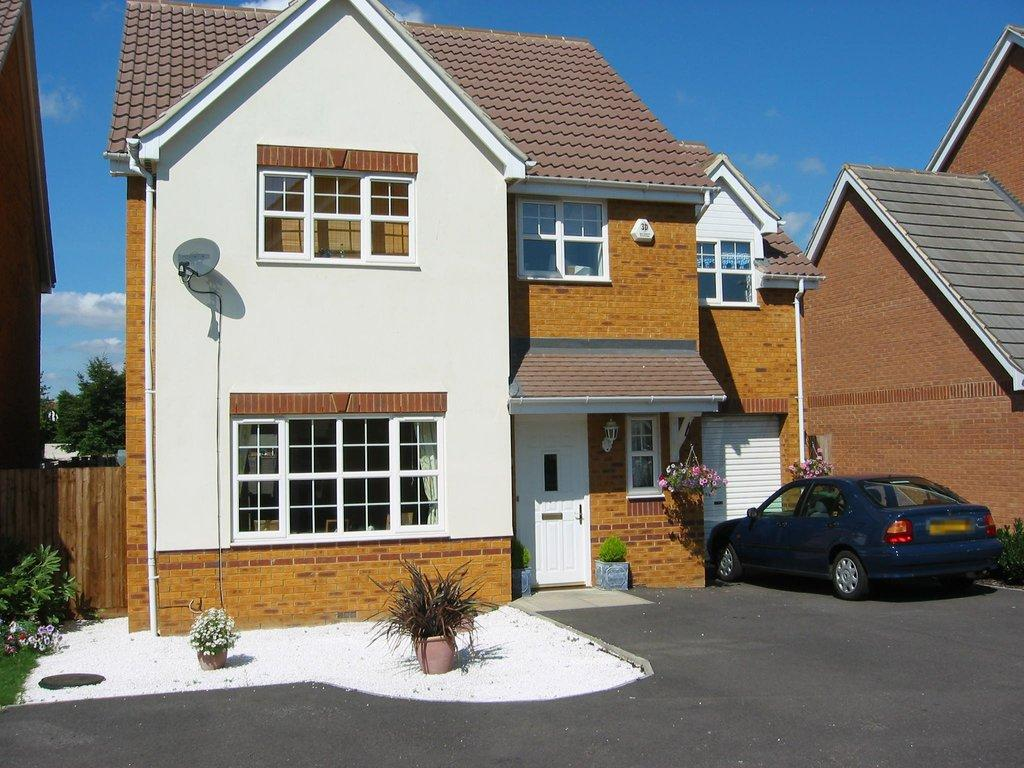What type of view is shown in the image? The image is a front view of a building. Is there any vehicle visible in the image? Yes, there is a car parked in front of the building. What else can be seen in the image besides the building and the car? There are plants visible in the image. Where is the shelf located in the image? There is no shelf present in the image. What type of joke can be seen on the building's facade in the image? There is no joke visible on the building's facade in the image. 